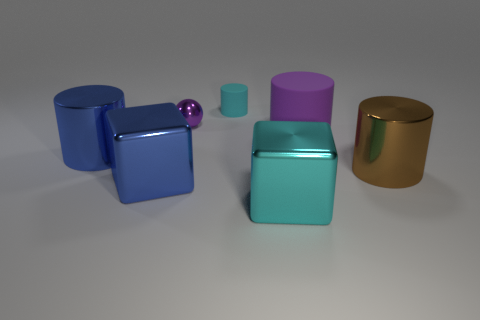Does the brown cylinder have the same material as the ball that is behind the big blue shiny cylinder?
Give a very brief answer. Yes. What is the size of the metal cube that is the same color as the small matte cylinder?
Make the answer very short. Large. Is there a small cylinder made of the same material as the small cyan object?
Offer a terse response. No. How many things are either large blue metal objects on the left side of the blue metal cube or purple things in front of the small sphere?
Your answer should be very brief. 2. There is a cyan rubber thing; does it have the same shape as the large blue metal object that is behind the brown metal object?
Your answer should be very brief. Yes. What number of other things are the same shape as the big purple object?
Your answer should be compact. 3. How many things are either big green metal cylinders or blue cylinders?
Provide a short and direct response. 1. Does the large matte object have the same color as the tiny metal object?
Your answer should be very brief. Yes. Is there any other thing that is the same size as the cyan block?
Make the answer very short. Yes. There is a metallic object behind the shiny cylinder left of the large brown object; what is its shape?
Provide a succinct answer. Sphere. 